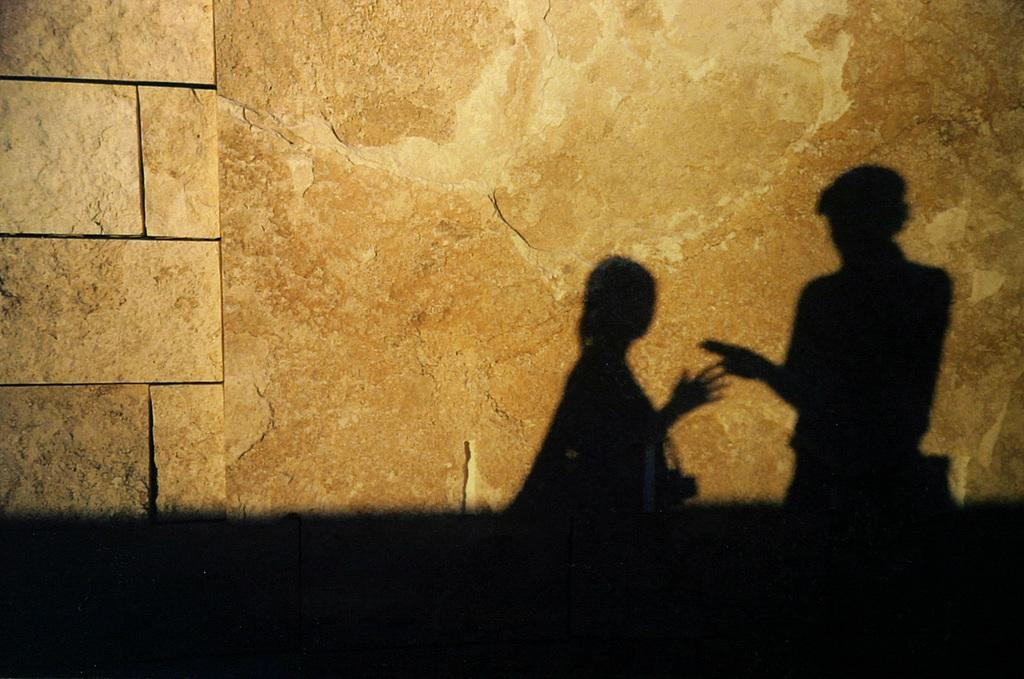What can be seen in the image that indicates the presence of people? There are shadows of persons in the image. Where are the shadows located? The shadows are on a wall. What type of tree is growing on the wall in the image? There is no tree growing on the wall in the image; the shadows are the only subjects present. 